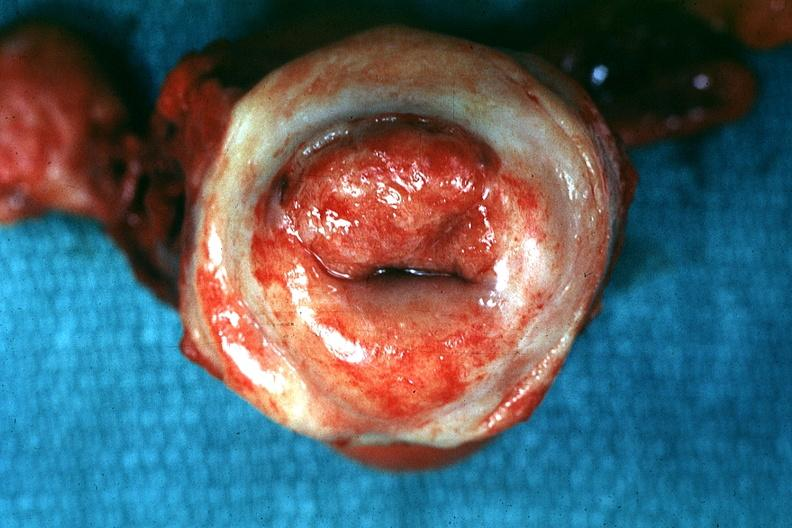s this photo of infant from head to toe present?
Answer the question using a single word or phrase. No 